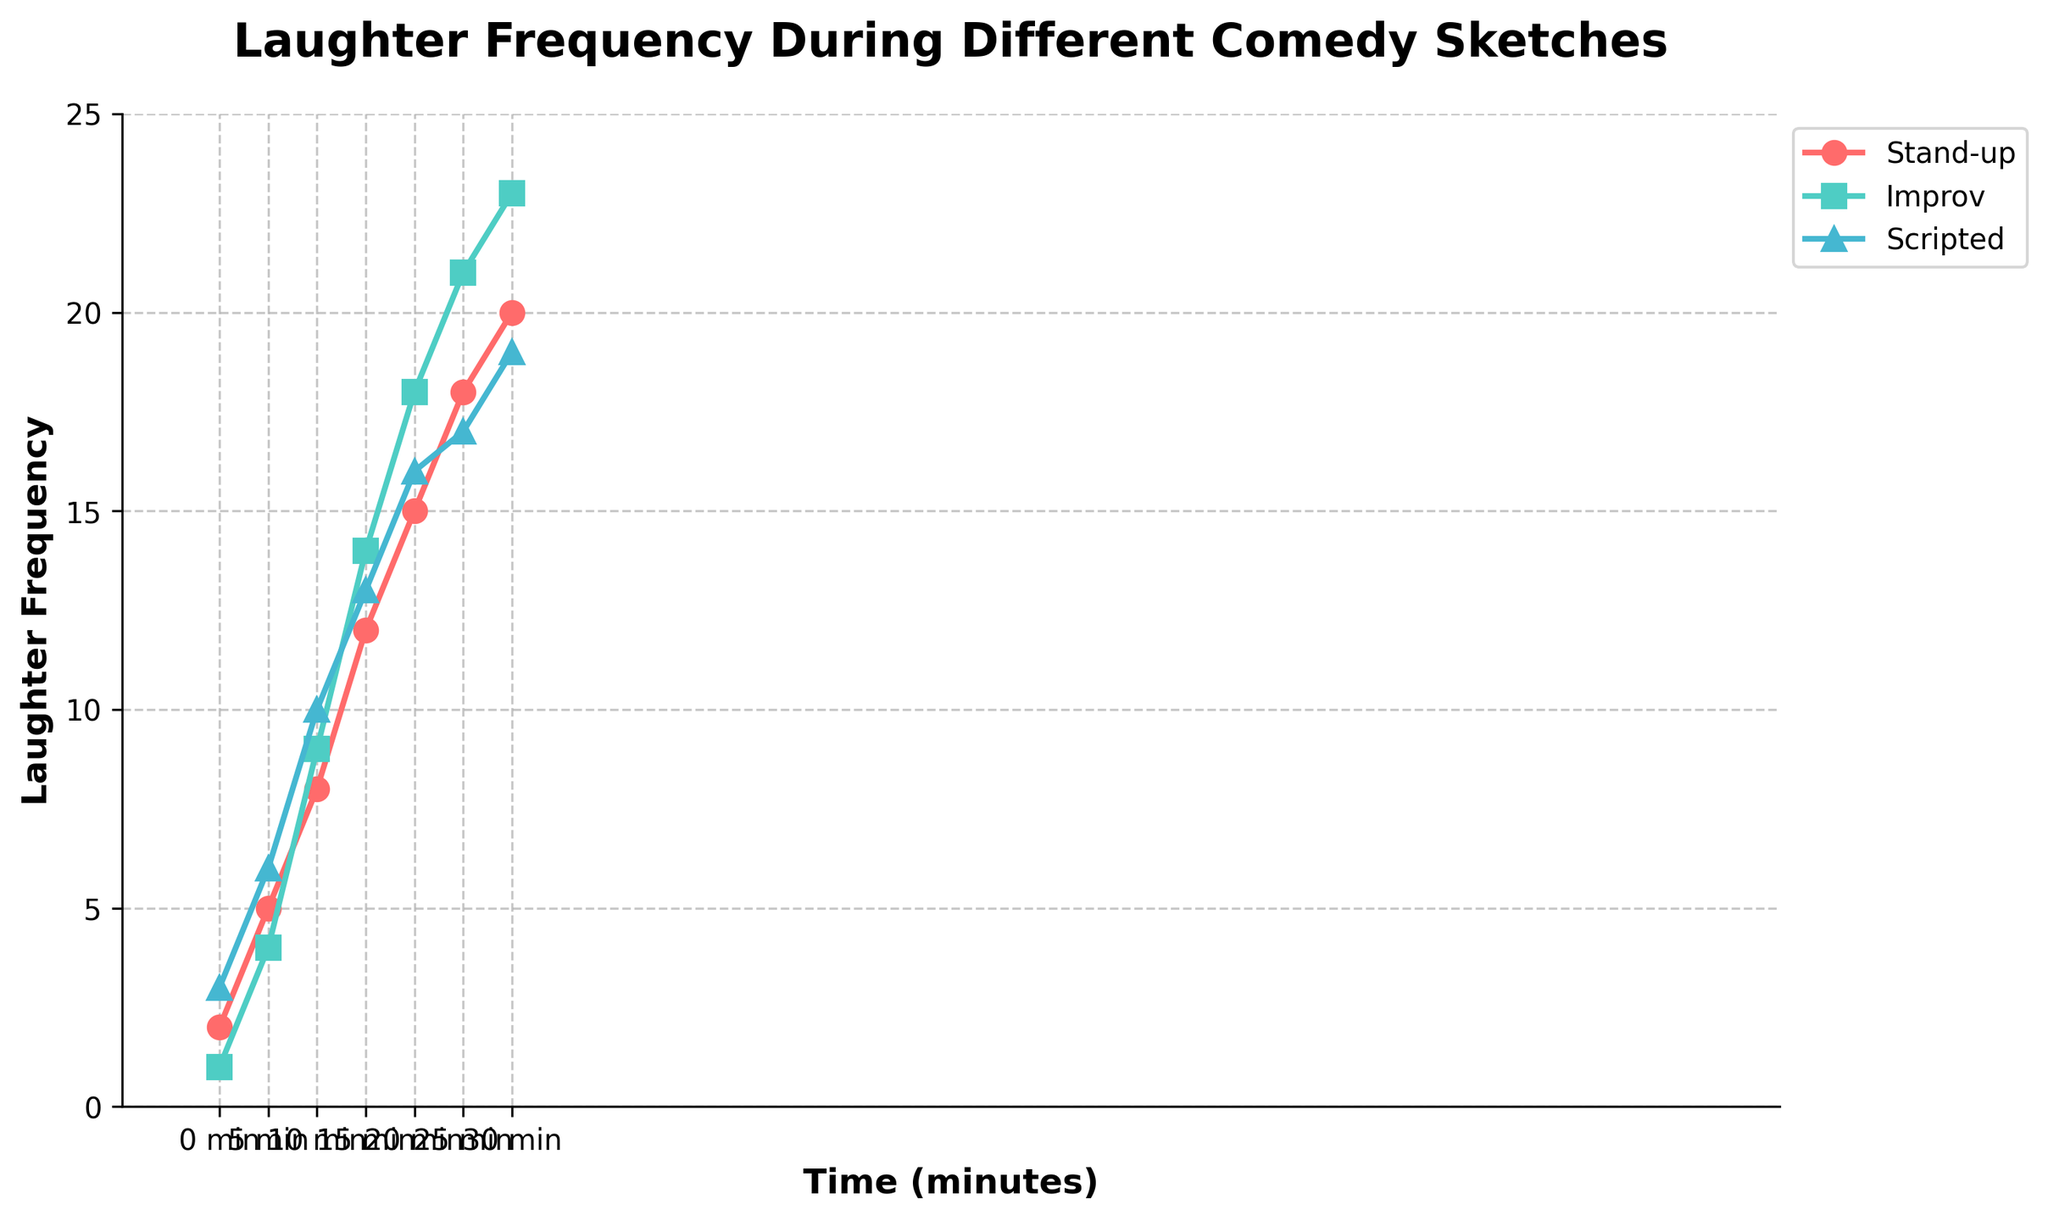What is the laughter frequency for the scripted comedy at the 10-minute mark? Check the value on the line corresponding to the scripted comedy at the 10-minute mark on the x-axis.
Answer: 10 Which comedy type has the highest laughter frequency at the 30-minute mark? Look at the values at the 30-minute mark on the x-axis for each comedy type and determine which one is the highest.
Answer: Improv How does the increase in laughter frequency from 5 minutes to 10 minutes compare between stand-up and improv sketches? For stand-up, the increase is from 5 to 8, which is 3. For improv, the increase is from 4 to 9, which is 5. Compare these values.
Answer: Improv has a greater increase What's the difference in laughter frequency at the 20-minute mark between stand-up and scripted sketches? Look at the values for stand-up and scripted sketches at the 20-minute mark and subtract the scripted value from the stand-up value (15 - 16).
Answer: -1 What is the average laughter frequency for improv sketches across the entire time range? Sum the values for improv sketches at all the time points (1, 4, 9, 14, 18, 21, 23) and divide by the number of time points (7). (1+4+9+14+18+21+23)/7 = 12.86.
Answer: 12.86 At which time point do all comedy types have similar laughter frequencies? Look for a time point where the laughter frequencies for all comedy types are close to each other visually (e.g., 20 minutes) - compare values for stand-up (15), improv (18), and scripted (16).
Answer: 20 minutes What is the total sum of laughter frequencies for the stand-up comedy type over the entire duration? Add up all the laughter frequencies for stand-up across the time points (2+5+8+12+15+18+20 = 80).
Answer: 80 Which comedy type shows the greatest overall increase in laughter frequency from the start to the end of the chart? Calculate the difference between the start (0 min) and the end (30 min) values for each type. Stand-up: 20-2=18, Improv: 23-1=22, Scripted: 19-3=16.
Answer: Improv How does the laughter frequency of the scripted comedy at 25 minutes compare with the improv comedy at the same time? Compare the values of scripted and improv comedy types at the 25-minute mark (scripted: 17, improv: 21).
Answer: Improv is higher 